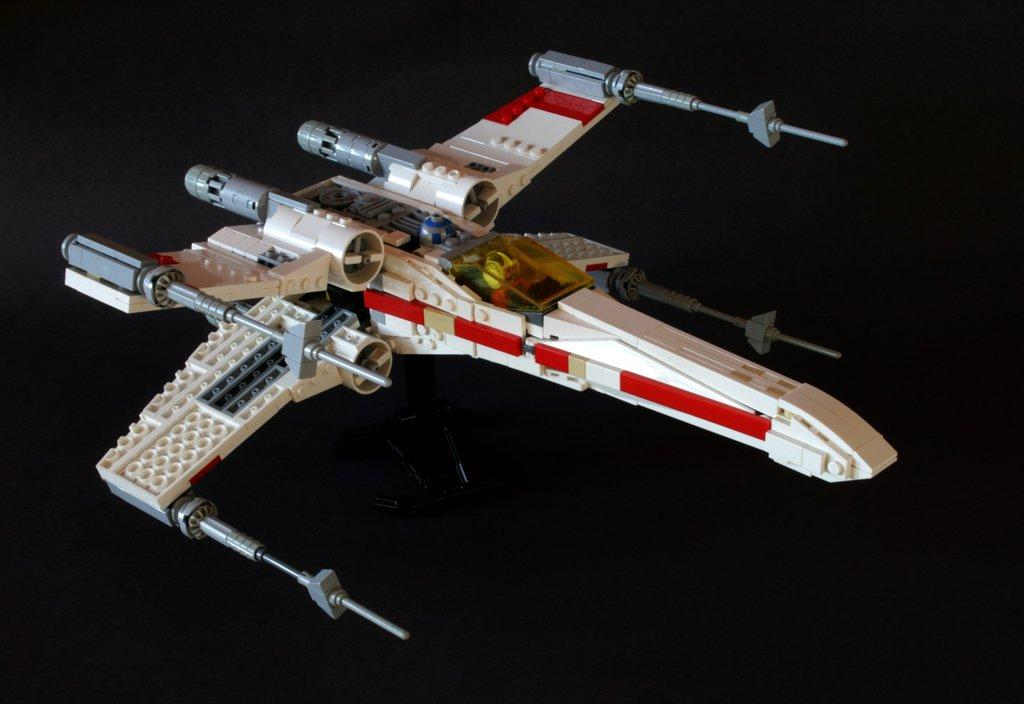What is the main object in the image? There is an aircraft toy in the image. Does the aircraft toy have any support? Yes, the aircraft toy has a stand. What color is the surface beneath the aircraft toy? The surface beneath the aircraft toy is black. What type of hat is the aircraft toy wearing in the image? There is no hat present on the aircraft toy in the image. How many rings are visible on the aircraft toy in the image? There are no rings visible on the aircraft toy in the image. 